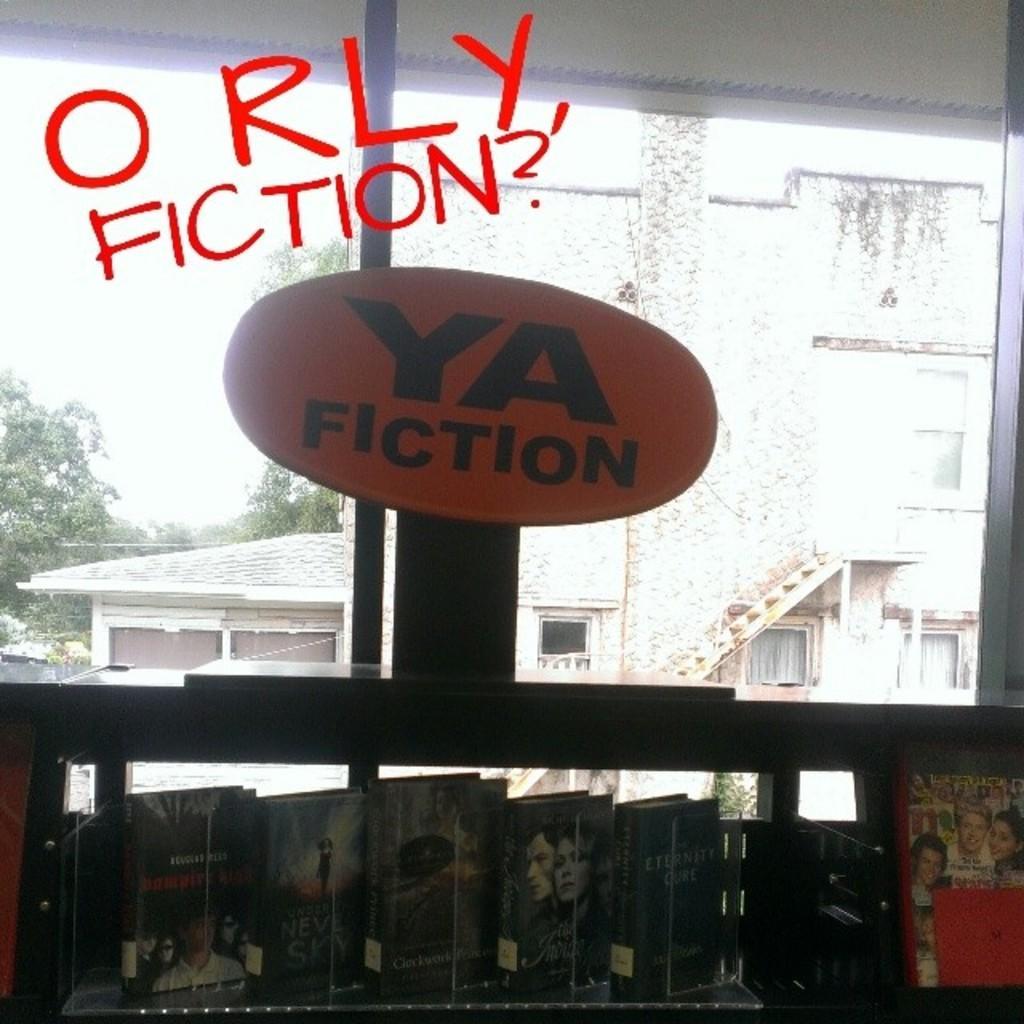How would you summarize this image in a sentence or two? In this image, we can see a shelf with some objects like books. We can also see some glass and a board with some text. We can see some houses, trees. We can also see the sky. We can see some text written on the image. 